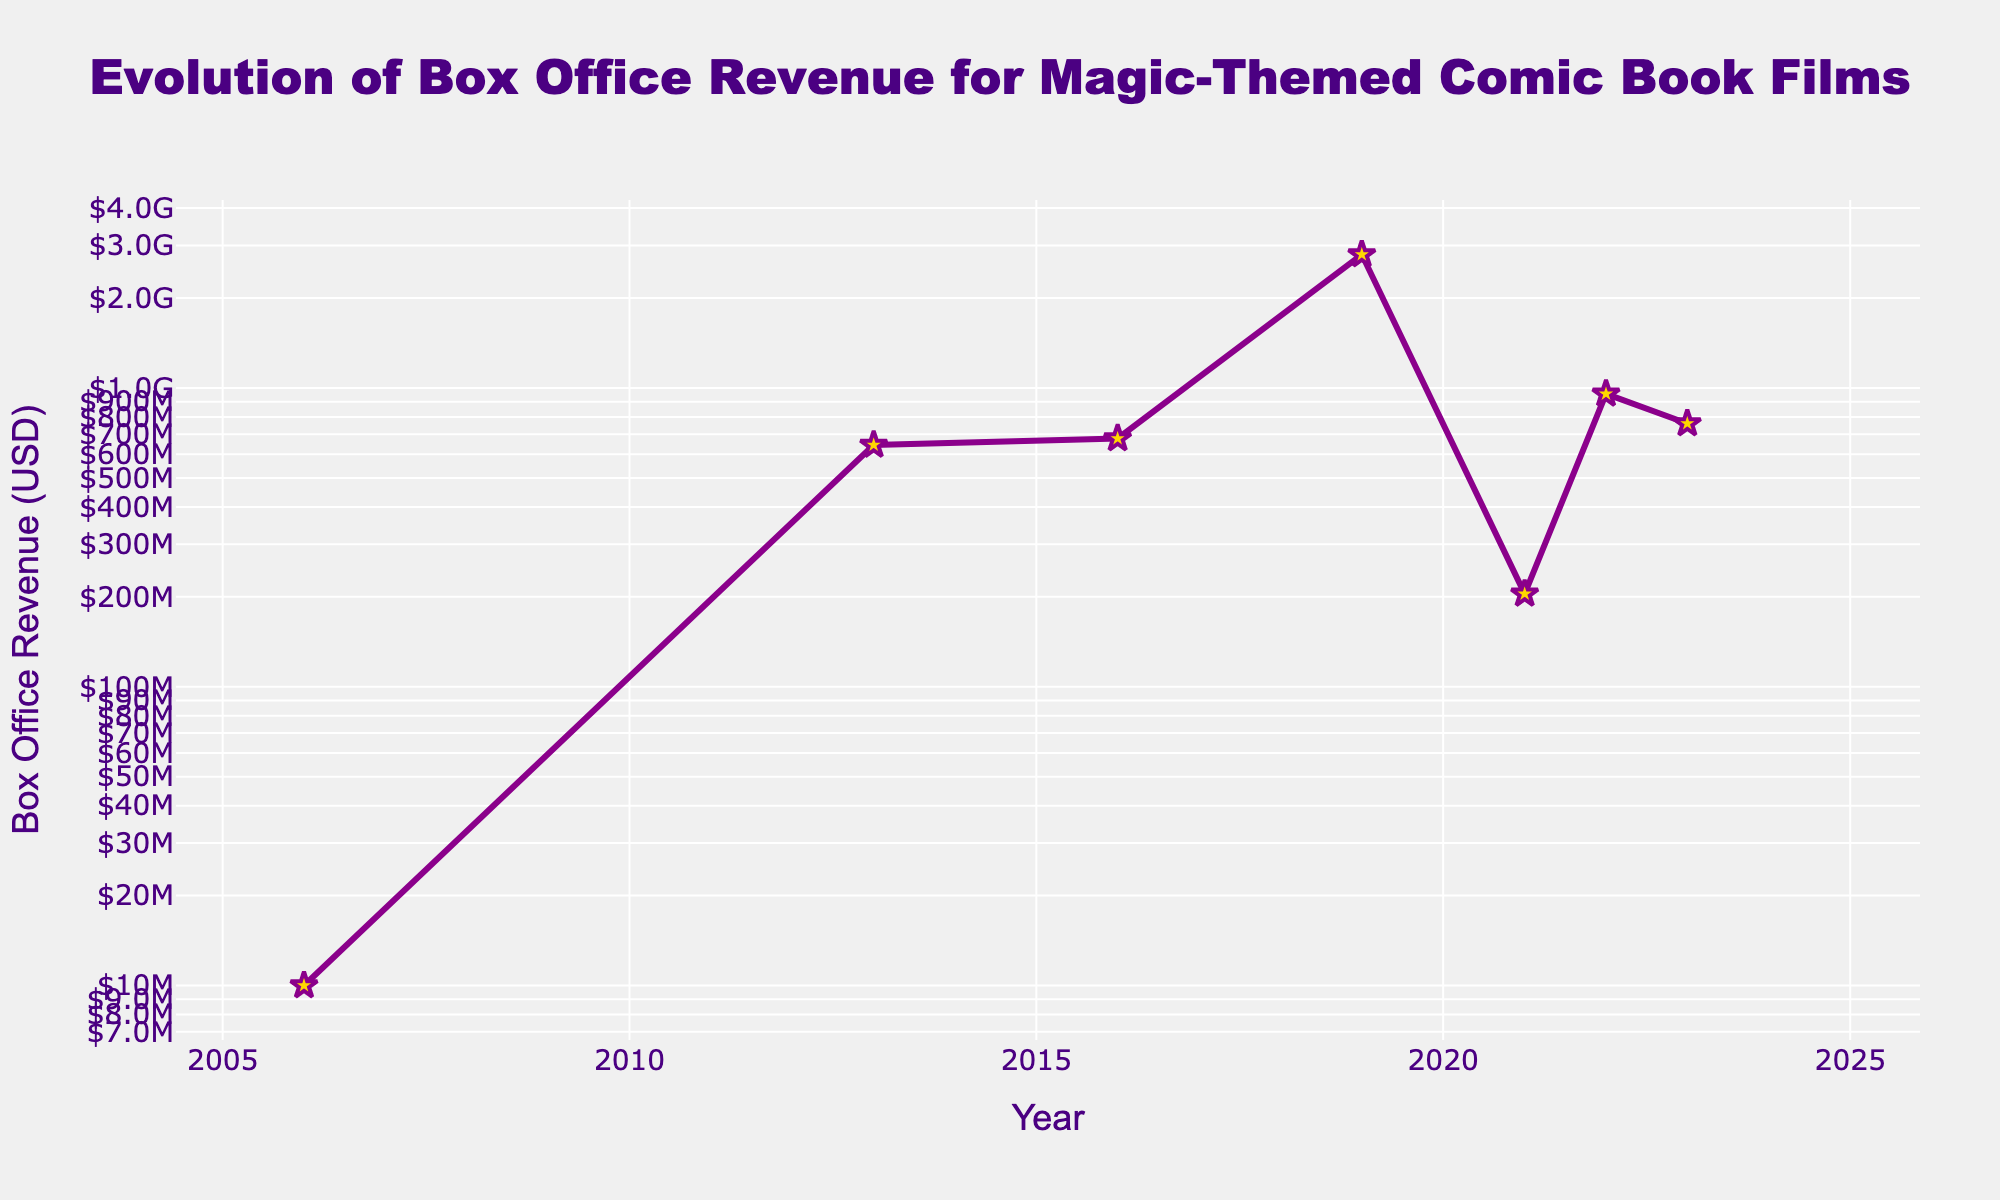What's the title of the plot? The title of the plot is displayed at the top center of the figure in large, bold font. It states, "Evolution of Box Office Revenue for Magic-Themed Comic Book Films."
Answer: Evolution of Box Office Revenue for Magic-Themed Comic Book Films How is the data represented on the plot? The data is represented using a line plot with markers. Each point on the plot corresponds to a specific year and the box office revenue for a film. The line connects these points, highlighting the trend over time.
Answer: Line plot with markers Which film achieved the highest box office revenue according to the plot? By observing the y-axis (log scale) and the annotations for each data point, "Avengers: Endgame (Doctor Strange)" in 2019 stands out as the highest box office revenue.
Answer: Avengers: Endgame (Doctor Strange) What film was released in 2016, and what was its box office revenue? The annotation at the 2016 data point indicates the film "Doctor Strange" with a box office revenue of approximately 677.7 million USD as marked by the plot.
Answer: Doctor Strange, 677.7 million USD Which year saw the largest increase in box office revenue compared to the previous year? We compare the differences between consecutive years. The jump from 2016 (677.7 million) to 2019 (2.798 billion) is the largest increase.
Answer: From 2016 to 2019 What is the general trend in the box office revenues for films over the years? Observing the line trend, there is a general increase in box office revenues for magic-themed comic book films over the years, peaking in 2019.
Answer: Increasing trend How many films are represented in the plot? Each annotation corresponds to a film, and there are seven annotations in the plot indicating seven films.
Answer: Seven films What was the box office revenue for "Ghostbusters: Afterlife" released in 2021? The marker and annotation for the year 2021 show the film "Ghostbusters: Afterlife" with a box office revenue of approximately 204.6 million USD.
Answer: 204.6 million USD Which two films have box office revenues closest to each other? By visually inspecting the plot, the revenue for "Thor: The Dark World" in 2013 (~644.6 million) and "Doctor Strange in the Multiverse of Madness" in 2022 (~955.8 million) are the closest when considering the log scale values.
Answer: Thor: The Dark World and Doctor Strange in the Multiverse of Madness 